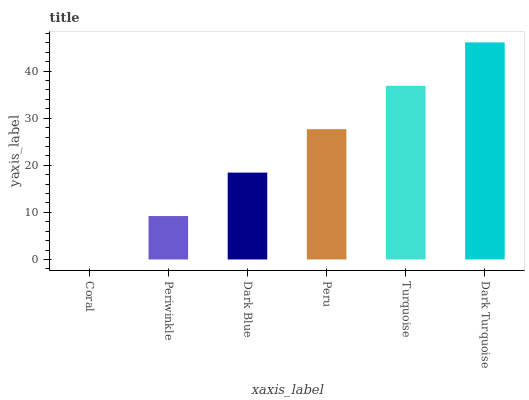Is Coral the minimum?
Answer yes or no. Yes. Is Dark Turquoise the maximum?
Answer yes or no. Yes. Is Periwinkle the minimum?
Answer yes or no. No. Is Periwinkle the maximum?
Answer yes or no. No. Is Periwinkle greater than Coral?
Answer yes or no. Yes. Is Coral less than Periwinkle?
Answer yes or no. Yes. Is Coral greater than Periwinkle?
Answer yes or no. No. Is Periwinkle less than Coral?
Answer yes or no. No. Is Peru the high median?
Answer yes or no. Yes. Is Dark Blue the low median?
Answer yes or no. Yes. Is Coral the high median?
Answer yes or no. No. Is Turquoise the low median?
Answer yes or no. No. 